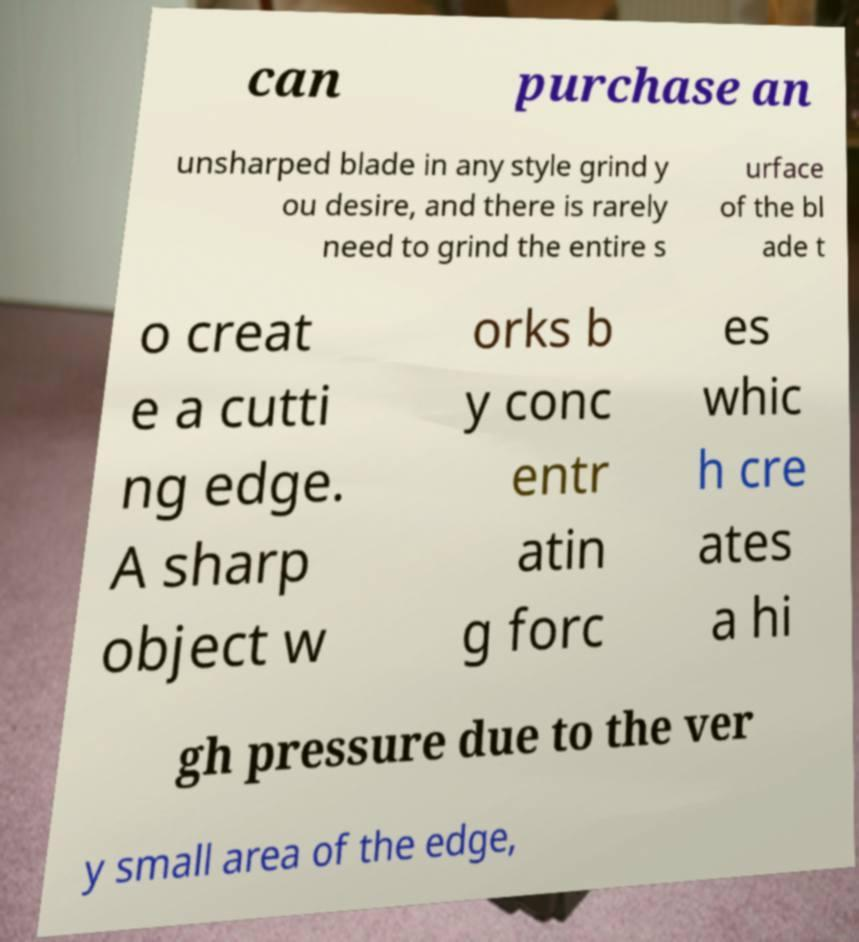Please read and relay the text visible in this image. What does it say? can purchase an unsharped blade in any style grind y ou desire, and there is rarely need to grind the entire s urface of the bl ade t o creat e a cutti ng edge. A sharp object w orks b y conc entr atin g forc es whic h cre ates a hi gh pressure due to the ver y small area of the edge, 